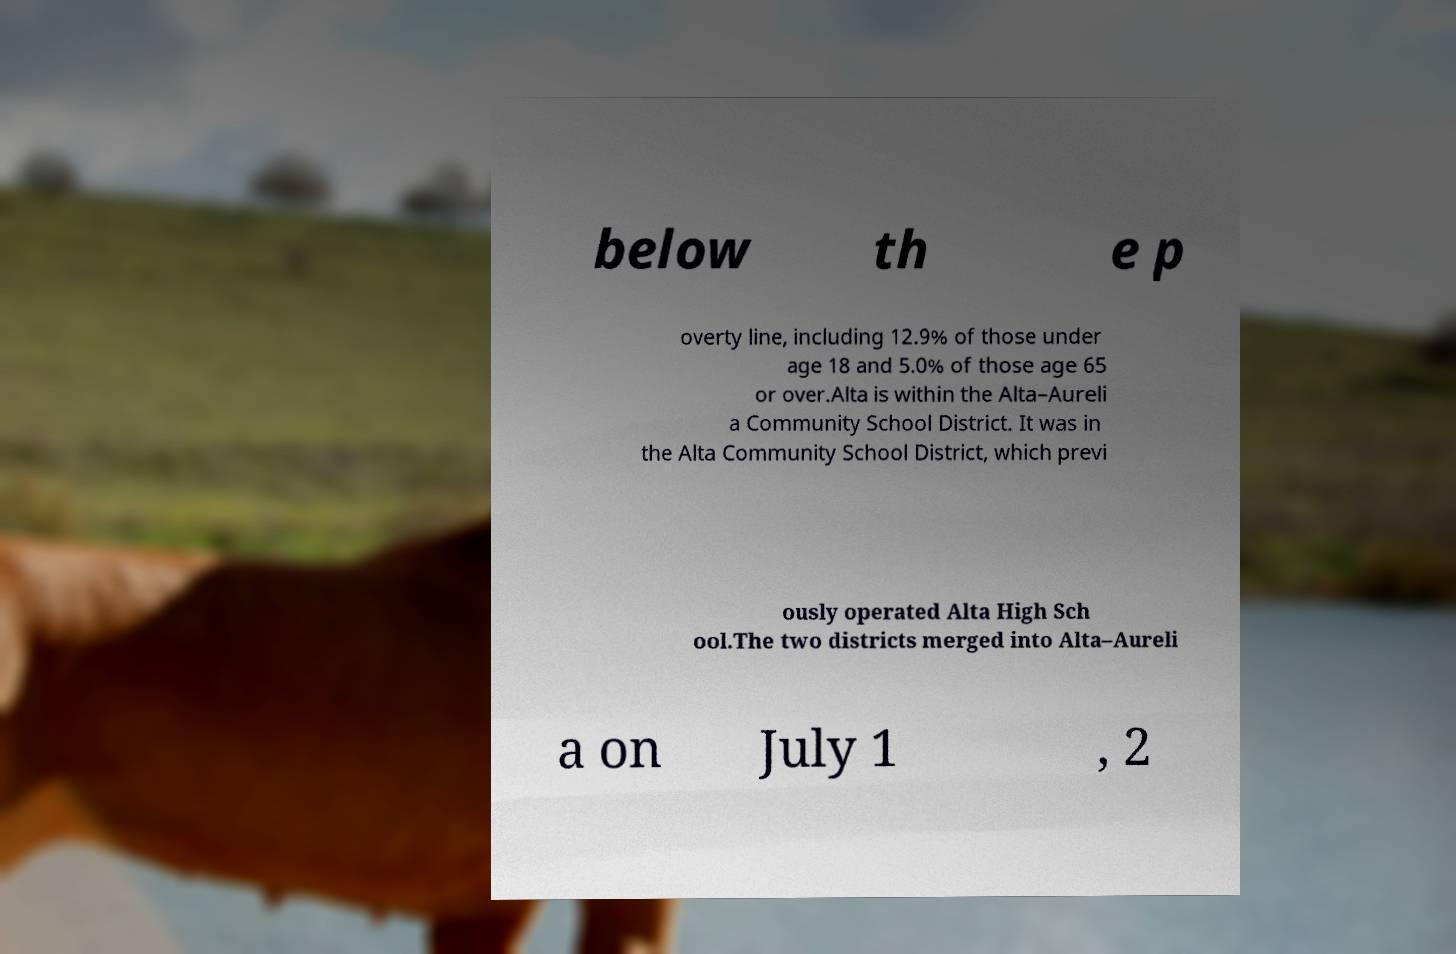What messages or text are displayed in this image? I need them in a readable, typed format. below th e p overty line, including 12.9% of those under age 18 and 5.0% of those age 65 or over.Alta is within the Alta–Aureli a Community School District. It was in the Alta Community School District, which previ ously operated Alta High Sch ool.The two districts merged into Alta–Aureli a on July 1 , 2 